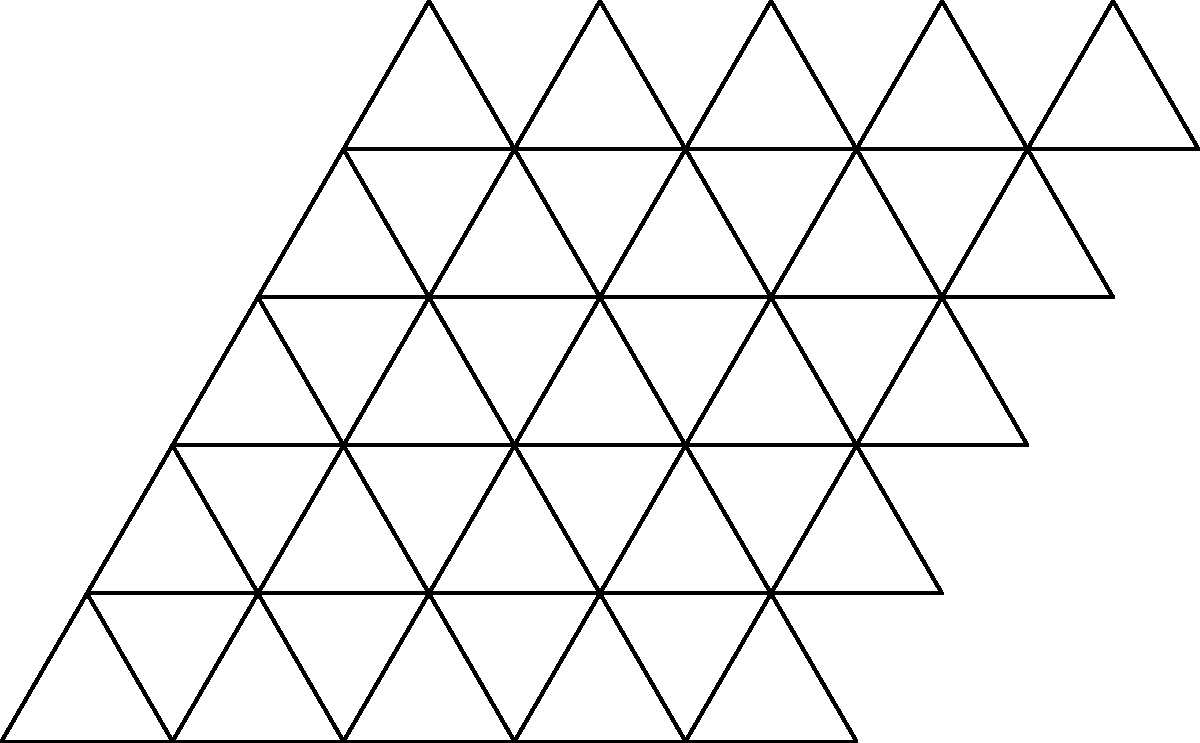In the tessellation pattern shown above, which poetic technique does the repeating triangular shape most closely resemble, and how might this be used to create a visually striking poem about the concept of infinity? 1. Observe the tessellation pattern: The image shows a repeating pattern of equilateral triangles that cover the plane without gaps or overlaps.

2. Identify the poetic technique: This pattern most closely resembles the repetition technique in poetry. Repetition is the deliberate use of words, phrases, or images multiple times for emphasis or rhythm.

3. Analyze the visual impact: The repeating triangles create a sense of continuity and endless expansion, which can be associated with the concept of infinity.

4. Consider the poetic application:
   a) Structure: The poet could arrange words or lines in triangular shapes on the page, mimicking the tessellation pattern.
   b) Content: Each triangle could represent a different aspect or perspective of infinity.
   c) Repetition: Key words or phrases could be repeated in each triangle, reinforcing the infinite nature of the pattern.

5. Visual poetry connection: This approach combines concrete poetry (where the arrangement of words on the page forms a picture) with the mathematical concept of tessellation, creating a unique visual and conceptual experience.

6. Infinity representation: The edges of the page would imply that the pattern continues indefinitely, symbolizing the boundless nature of infinity.

By using this tessellation-inspired structure, the poet can create a visually striking poem that not only discusses infinity but also represents it through its form and repetition.
Answer: Repetition, arranged in a triangular tessellation pattern to visually represent infinity 